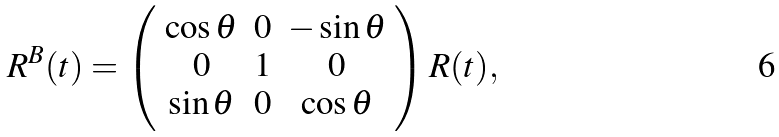<formula> <loc_0><loc_0><loc_500><loc_500>R ^ { B } ( t ) = \left ( \begin{array} { c c c } \cos \theta & 0 & - \sin \theta \\ 0 & 1 & 0 \\ \sin \theta & 0 & \cos \theta \end{array} \right ) R ( t ) ,</formula> 